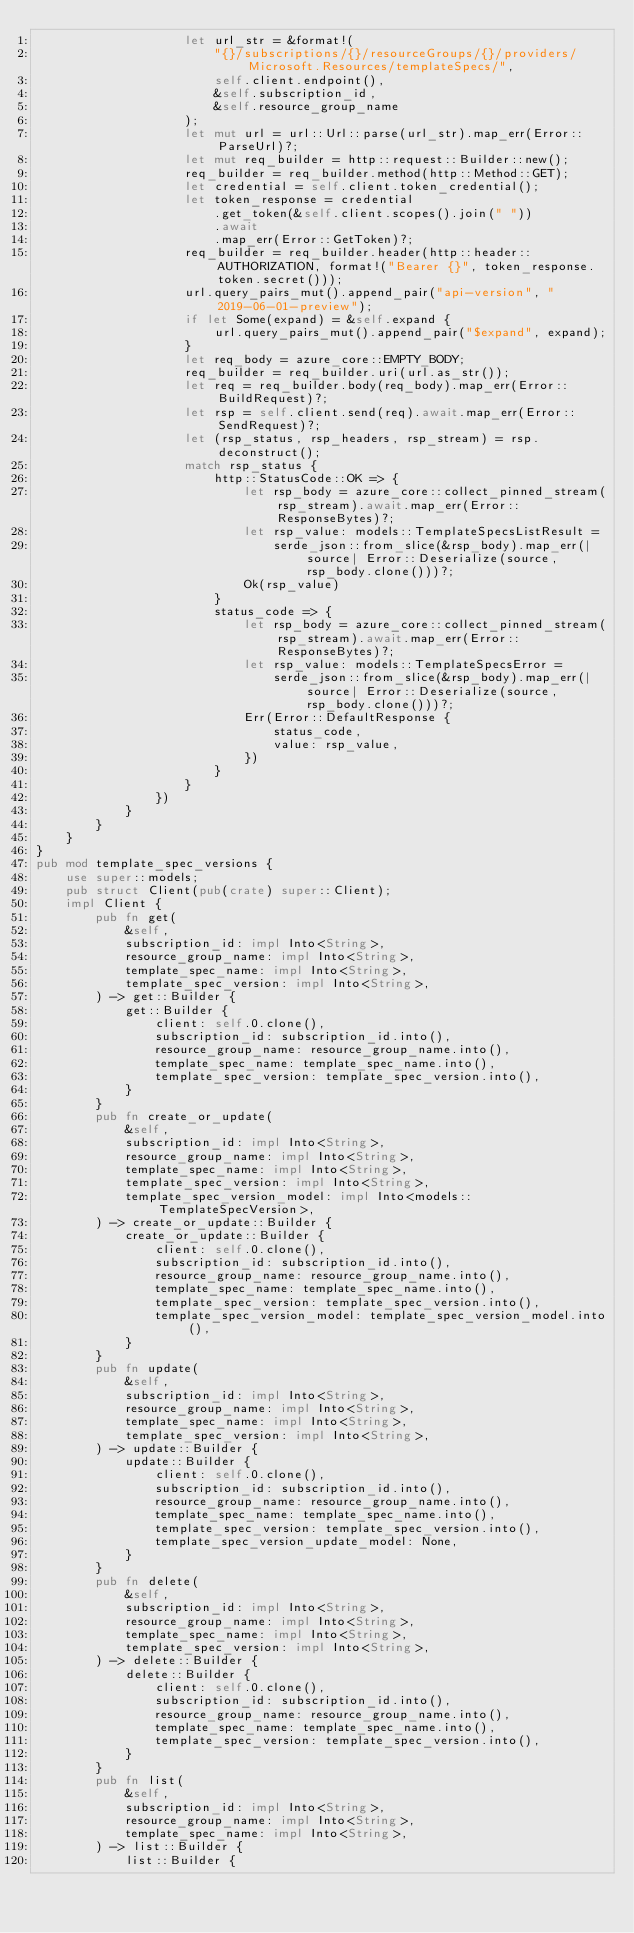Convert code to text. <code><loc_0><loc_0><loc_500><loc_500><_Rust_>                    let url_str = &format!(
                        "{}/subscriptions/{}/resourceGroups/{}/providers/Microsoft.Resources/templateSpecs/",
                        self.client.endpoint(),
                        &self.subscription_id,
                        &self.resource_group_name
                    );
                    let mut url = url::Url::parse(url_str).map_err(Error::ParseUrl)?;
                    let mut req_builder = http::request::Builder::new();
                    req_builder = req_builder.method(http::Method::GET);
                    let credential = self.client.token_credential();
                    let token_response = credential
                        .get_token(&self.client.scopes().join(" "))
                        .await
                        .map_err(Error::GetToken)?;
                    req_builder = req_builder.header(http::header::AUTHORIZATION, format!("Bearer {}", token_response.token.secret()));
                    url.query_pairs_mut().append_pair("api-version", "2019-06-01-preview");
                    if let Some(expand) = &self.expand {
                        url.query_pairs_mut().append_pair("$expand", expand);
                    }
                    let req_body = azure_core::EMPTY_BODY;
                    req_builder = req_builder.uri(url.as_str());
                    let req = req_builder.body(req_body).map_err(Error::BuildRequest)?;
                    let rsp = self.client.send(req).await.map_err(Error::SendRequest)?;
                    let (rsp_status, rsp_headers, rsp_stream) = rsp.deconstruct();
                    match rsp_status {
                        http::StatusCode::OK => {
                            let rsp_body = azure_core::collect_pinned_stream(rsp_stream).await.map_err(Error::ResponseBytes)?;
                            let rsp_value: models::TemplateSpecsListResult =
                                serde_json::from_slice(&rsp_body).map_err(|source| Error::Deserialize(source, rsp_body.clone()))?;
                            Ok(rsp_value)
                        }
                        status_code => {
                            let rsp_body = azure_core::collect_pinned_stream(rsp_stream).await.map_err(Error::ResponseBytes)?;
                            let rsp_value: models::TemplateSpecsError =
                                serde_json::from_slice(&rsp_body).map_err(|source| Error::Deserialize(source, rsp_body.clone()))?;
                            Err(Error::DefaultResponse {
                                status_code,
                                value: rsp_value,
                            })
                        }
                    }
                })
            }
        }
    }
}
pub mod template_spec_versions {
    use super::models;
    pub struct Client(pub(crate) super::Client);
    impl Client {
        pub fn get(
            &self,
            subscription_id: impl Into<String>,
            resource_group_name: impl Into<String>,
            template_spec_name: impl Into<String>,
            template_spec_version: impl Into<String>,
        ) -> get::Builder {
            get::Builder {
                client: self.0.clone(),
                subscription_id: subscription_id.into(),
                resource_group_name: resource_group_name.into(),
                template_spec_name: template_spec_name.into(),
                template_spec_version: template_spec_version.into(),
            }
        }
        pub fn create_or_update(
            &self,
            subscription_id: impl Into<String>,
            resource_group_name: impl Into<String>,
            template_spec_name: impl Into<String>,
            template_spec_version: impl Into<String>,
            template_spec_version_model: impl Into<models::TemplateSpecVersion>,
        ) -> create_or_update::Builder {
            create_or_update::Builder {
                client: self.0.clone(),
                subscription_id: subscription_id.into(),
                resource_group_name: resource_group_name.into(),
                template_spec_name: template_spec_name.into(),
                template_spec_version: template_spec_version.into(),
                template_spec_version_model: template_spec_version_model.into(),
            }
        }
        pub fn update(
            &self,
            subscription_id: impl Into<String>,
            resource_group_name: impl Into<String>,
            template_spec_name: impl Into<String>,
            template_spec_version: impl Into<String>,
        ) -> update::Builder {
            update::Builder {
                client: self.0.clone(),
                subscription_id: subscription_id.into(),
                resource_group_name: resource_group_name.into(),
                template_spec_name: template_spec_name.into(),
                template_spec_version: template_spec_version.into(),
                template_spec_version_update_model: None,
            }
        }
        pub fn delete(
            &self,
            subscription_id: impl Into<String>,
            resource_group_name: impl Into<String>,
            template_spec_name: impl Into<String>,
            template_spec_version: impl Into<String>,
        ) -> delete::Builder {
            delete::Builder {
                client: self.0.clone(),
                subscription_id: subscription_id.into(),
                resource_group_name: resource_group_name.into(),
                template_spec_name: template_spec_name.into(),
                template_spec_version: template_spec_version.into(),
            }
        }
        pub fn list(
            &self,
            subscription_id: impl Into<String>,
            resource_group_name: impl Into<String>,
            template_spec_name: impl Into<String>,
        ) -> list::Builder {
            list::Builder {</code> 